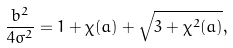<formula> <loc_0><loc_0><loc_500><loc_500>\frac { b ^ { 2 } } { 4 \sigma ^ { 2 } } = 1 + \chi ( a ) + \sqrt { 3 + \chi ^ { 2 } ( a ) } ,</formula> 